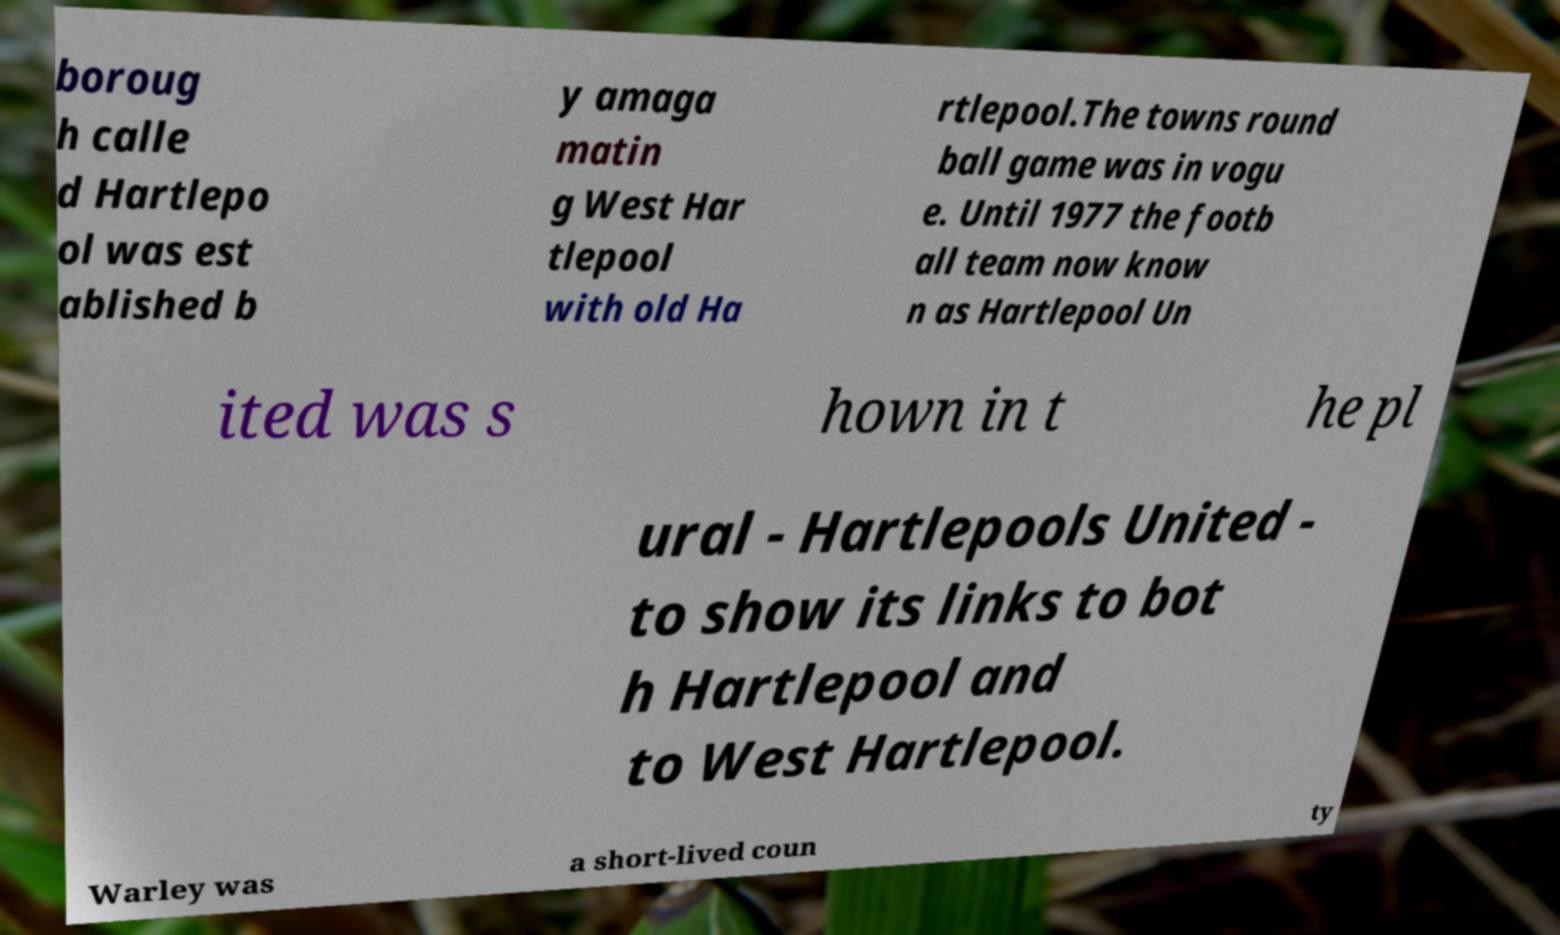For documentation purposes, I need the text within this image transcribed. Could you provide that? boroug h calle d Hartlepo ol was est ablished b y amaga matin g West Har tlepool with old Ha rtlepool.The towns round ball game was in vogu e. Until 1977 the footb all team now know n as Hartlepool Un ited was s hown in t he pl ural - Hartlepools United - to show its links to bot h Hartlepool and to West Hartlepool. Warley was a short-lived coun ty 